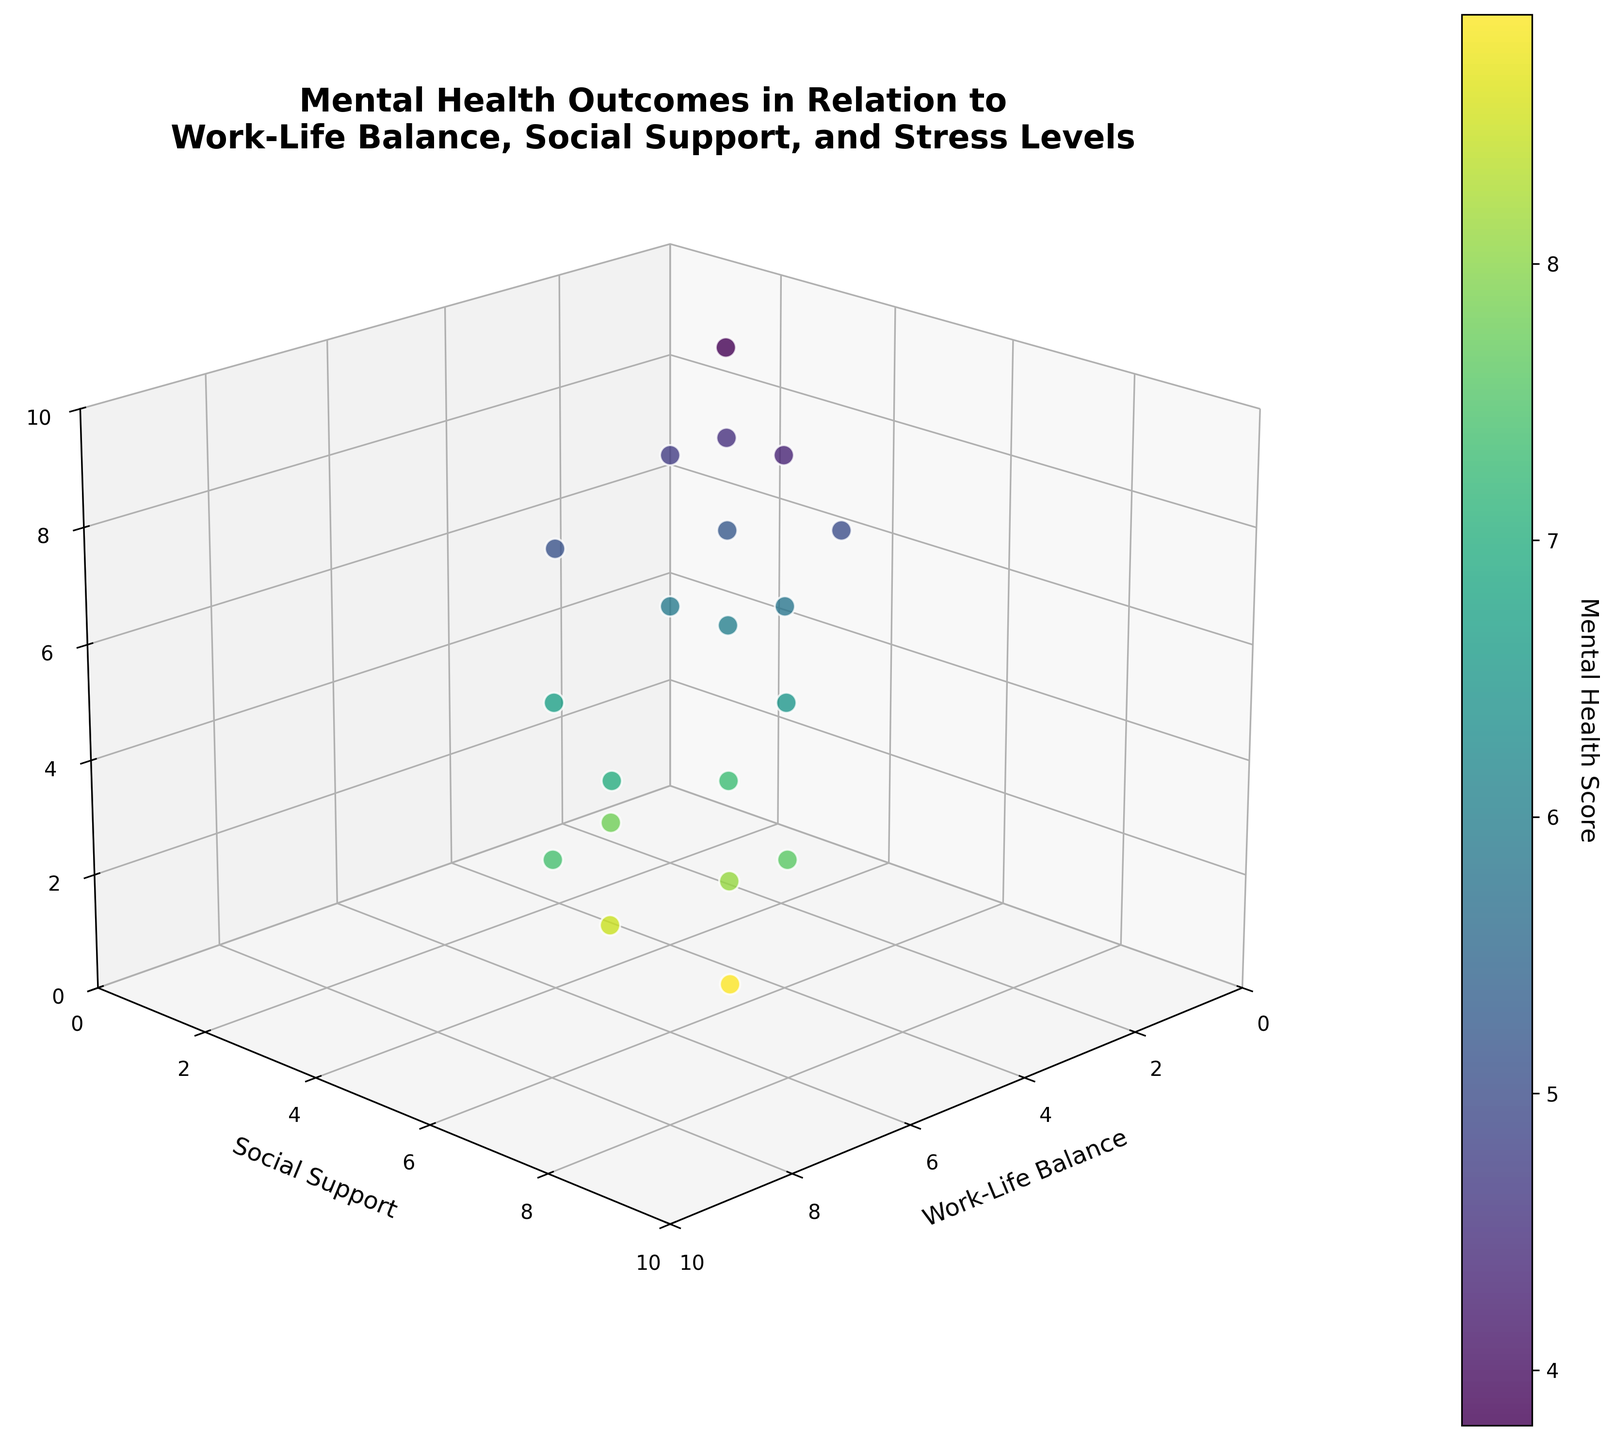What is the title of the plot? The title is prominently displayed at the top of the figure. It encapsulates the main theme of the plot.
Answer: Mental Health Outcomes in Relation to Work-Life Balance, Social Support, and Stress Levels What is represented on the x-axis? The axis labels are clearly marked, indicating what each axis measures.
Answer: Work-Life Balance How many data points are plotted in the figure? You can count the individual data points represented by the scatter plot dots.
Answer: 20 Which data point has the highest level of social support? By examining the y-axis (Social Support) and identifying the data point with the highest value, we can find the answer.
Answer: The data point at (7, 8, 2) What is the range of the stress levels depicted in the scatter plot? The z-axis (Stress Level) has minimum and maximum values which show the range.
Answer: 2 to 9 Which factor seems to have a stronger relationship with the mental health score: work-life balance or stress level? By comparing the color gradient (representing mental health score) across the axes, we can infer which factor correlates more strongly.
Answer: Work-Life Balance If a person has a work-life balance score of 3 and a social support score of 4, what is the approximate mental health score? Identifying the data point with these x and y values and observing the color gradient that reflects the mental health score.
Answer: Approximately 5.2 Which data point has the lowest mental health score, and what are its work-life balance and social support values? By finding the data point with the darkest shade, we can then read its x and y-axis values.
Answer: (1, 2, 9) Is there a general trend between stress levels and mental health scores? By examining the z-axis (Stress Level) and looking for a consistent pattern in the color gradient, we can identify any trend.
Answer: Higher stress levels generally correlate with lower mental health scores How does social support impact mental health scores in individuals with a work-life balance of 6? Observing the points along the x = 6 line and noting the variation in color along the y-axis (Social Support).
Answer: Higher social support with a work-life balance of 6 correlates with better mental health scores 